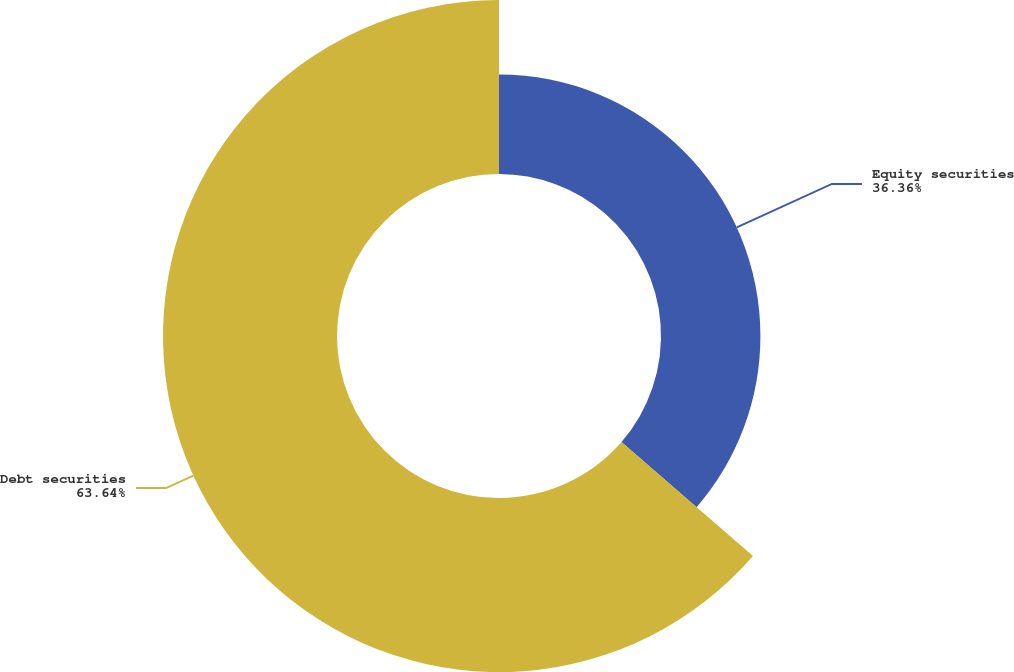Convert chart. <chart><loc_0><loc_0><loc_500><loc_500><pie_chart><fcel>Equity securities<fcel>Debt securities<nl><fcel>36.36%<fcel>63.64%<nl></chart> 